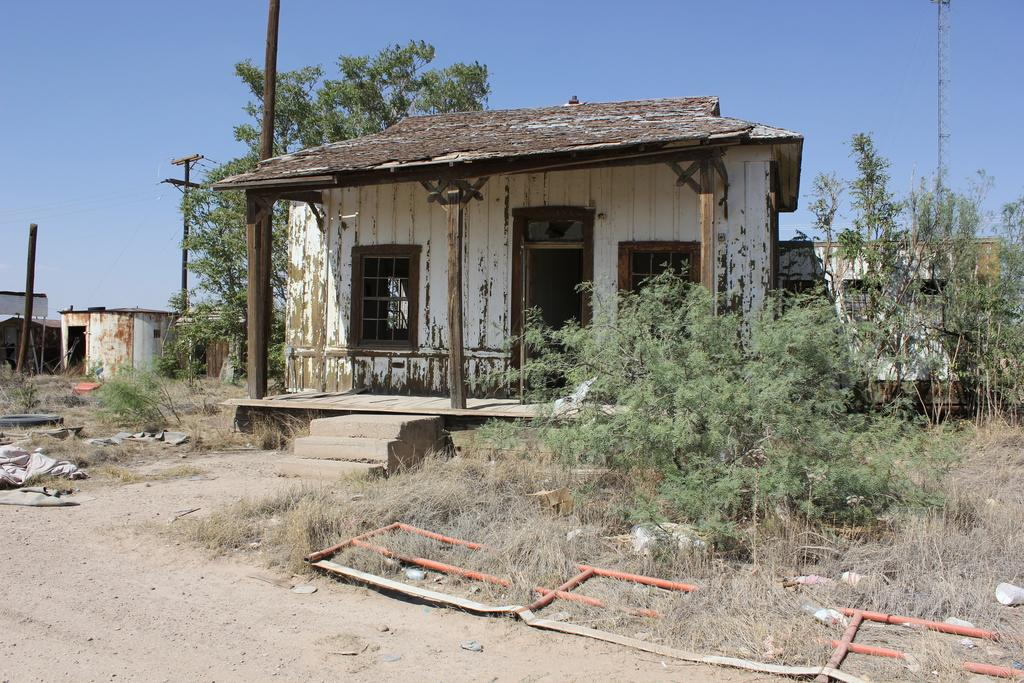What type of structures can be seen in the image? There are houses in the image. What else can be seen in the image besides houses? There are poles, trees, and grass visible in the image. What feature of the houses is mentioned in the facts? The houses have windows. What is visible in the background of the image? The sky is visible in the background of the image. What type of teaching is the carpenter providing in the image? There is no carpenter or teaching present in the image. What is inside the sack that is visible in the image? There is no sack present in the image. 